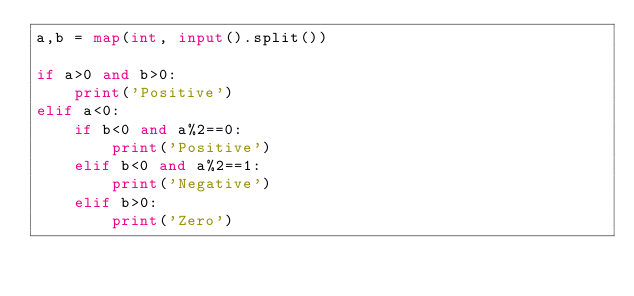<code> <loc_0><loc_0><loc_500><loc_500><_Python_>a,b = map(int, input().split())

if a>0 and b>0:
    print('Positive')
elif a<0:
    if b<0 and a%2==0:
        print('Positive')
    elif b<0 and a%2==1:
        print('Negative')
    elif b>0:
        print('Zero')</code> 